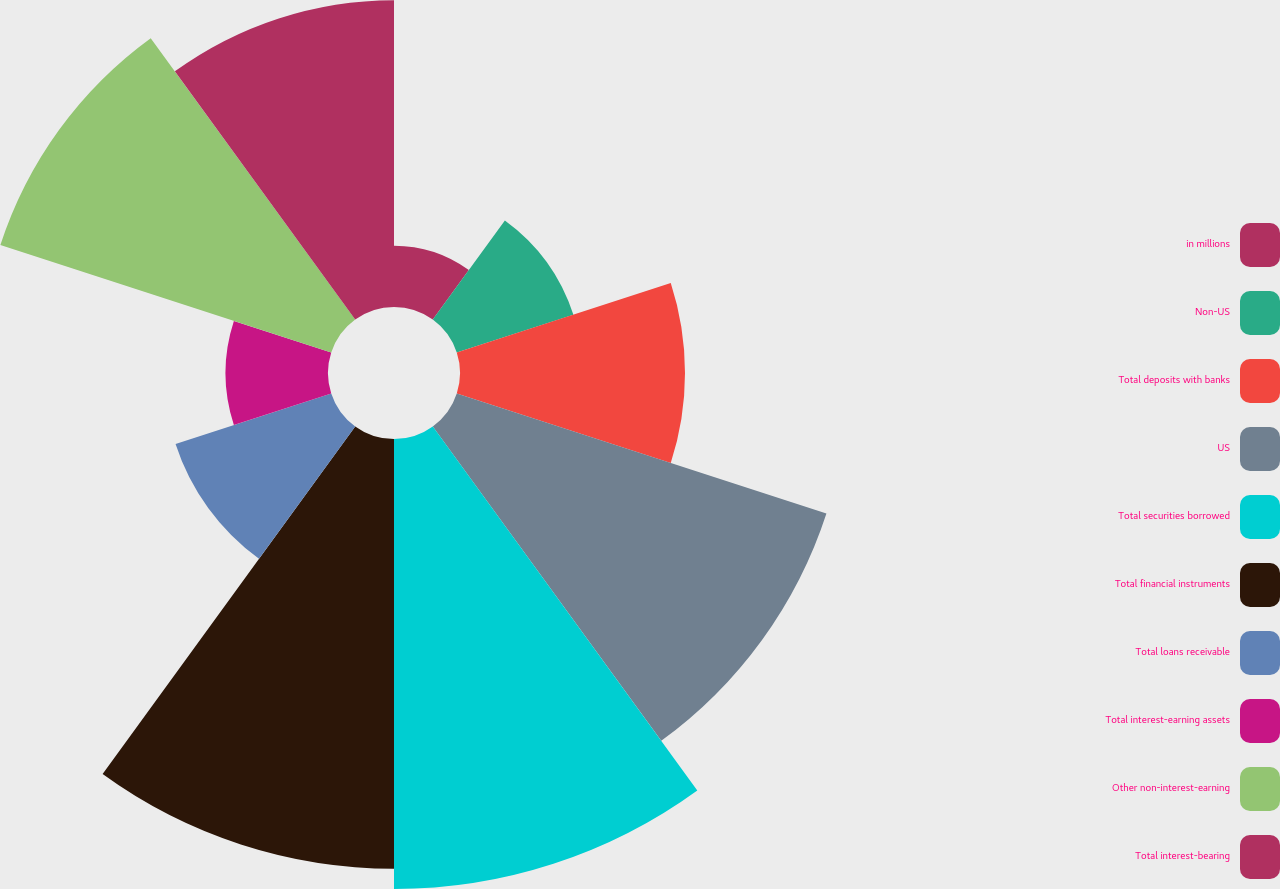Convert chart to OTSL. <chart><loc_0><loc_0><loc_500><loc_500><pie_chart><fcel>in millions<fcel>Non-US<fcel>Total deposits with banks<fcel>US<fcel>Total securities borrowed<fcel>Total financial instruments<fcel>Total loans receivable<fcel>Total interest-earning assets<fcel>Other non-interest-earning<fcel>Total interest-bearing<nl><fcel>2.36%<fcel>4.72%<fcel>8.66%<fcel>14.96%<fcel>17.32%<fcel>16.54%<fcel>6.3%<fcel>3.94%<fcel>13.39%<fcel>11.81%<nl></chart> 